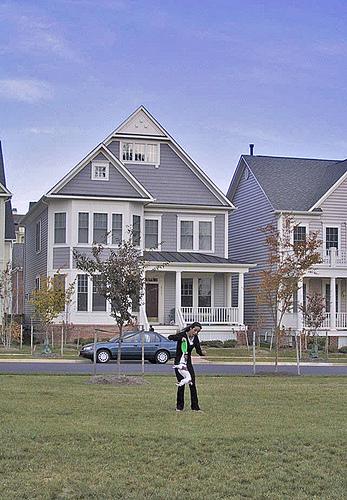What color is the car?
Write a very short answer. Blue. What is hanging off the frisbee?
Write a very short answer. Dog. Is the person having fun?
Answer briefly. Yes. 